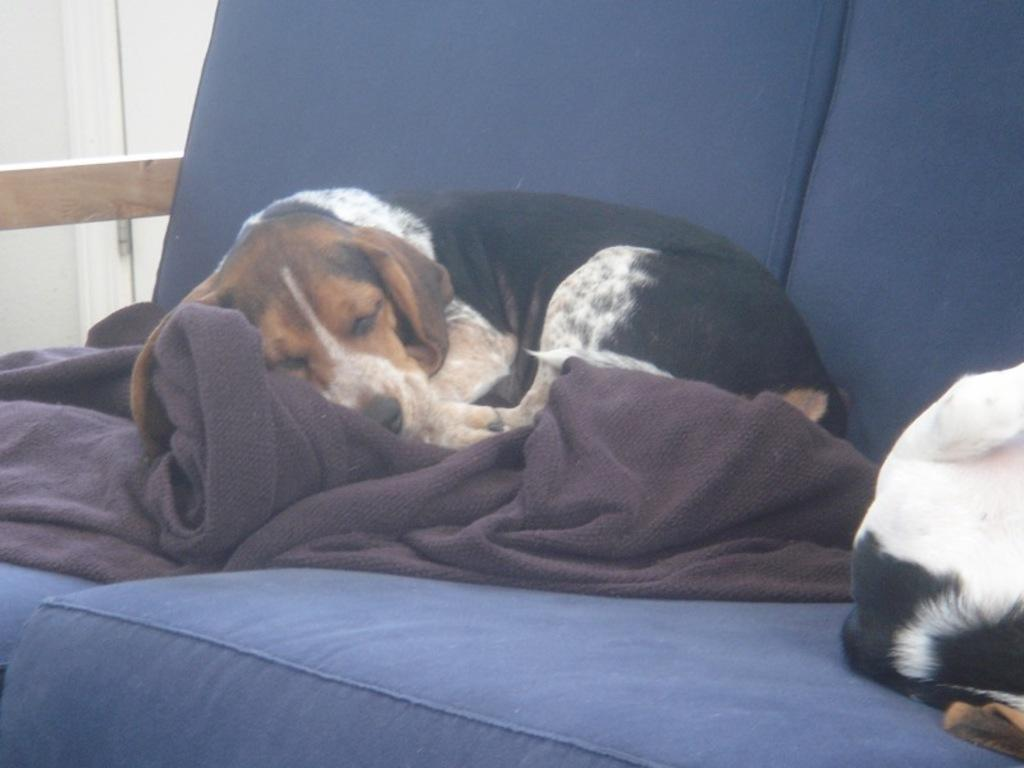What type of furniture is present in the image? There is a sofa in the image. What is covering the sofa? There is a blanket on the sofa. What animal can be seen on the sofa? There is a dog on the sofa. Are there any other animals on the sofa? Yes, there is another animal on the sofa. What type of leaf is being used as a plate by the dog in the image? There is no leaf or plate present in the image, and the dog is not interacting with any such objects. 